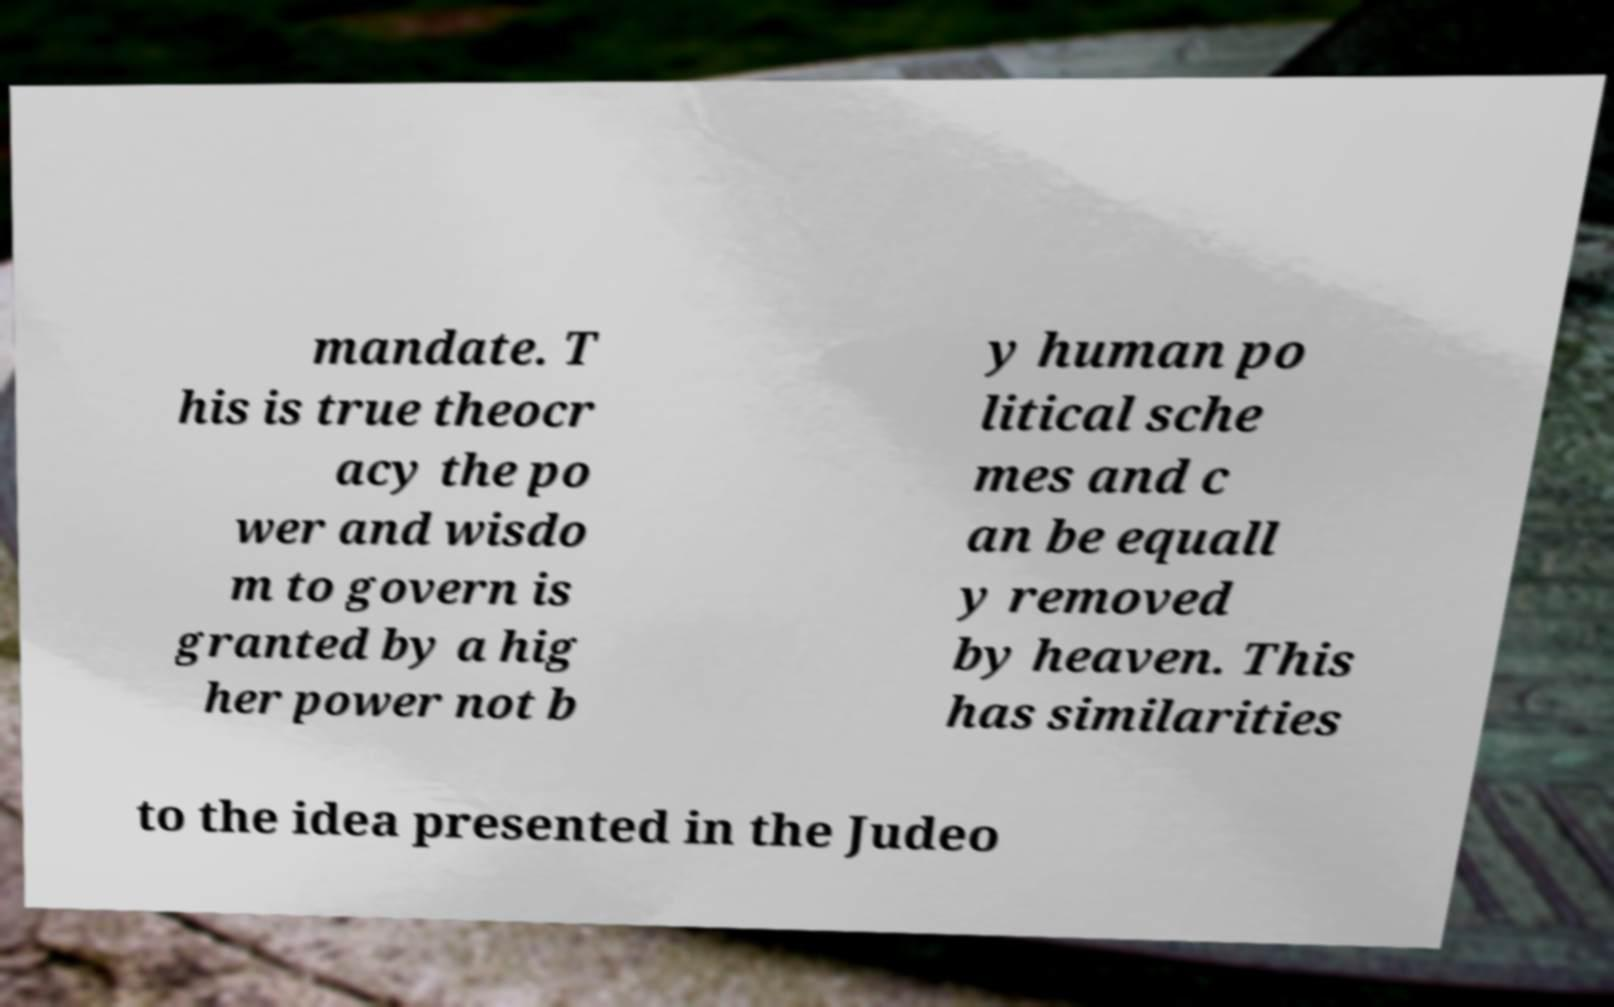Could you assist in decoding the text presented in this image and type it out clearly? mandate. T his is true theocr acy the po wer and wisdo m to govern is granted by a hig her power not b y human po litical sche mes and c an be equall y removed by heaven. This has similarities to the idea presented in the Judeo 